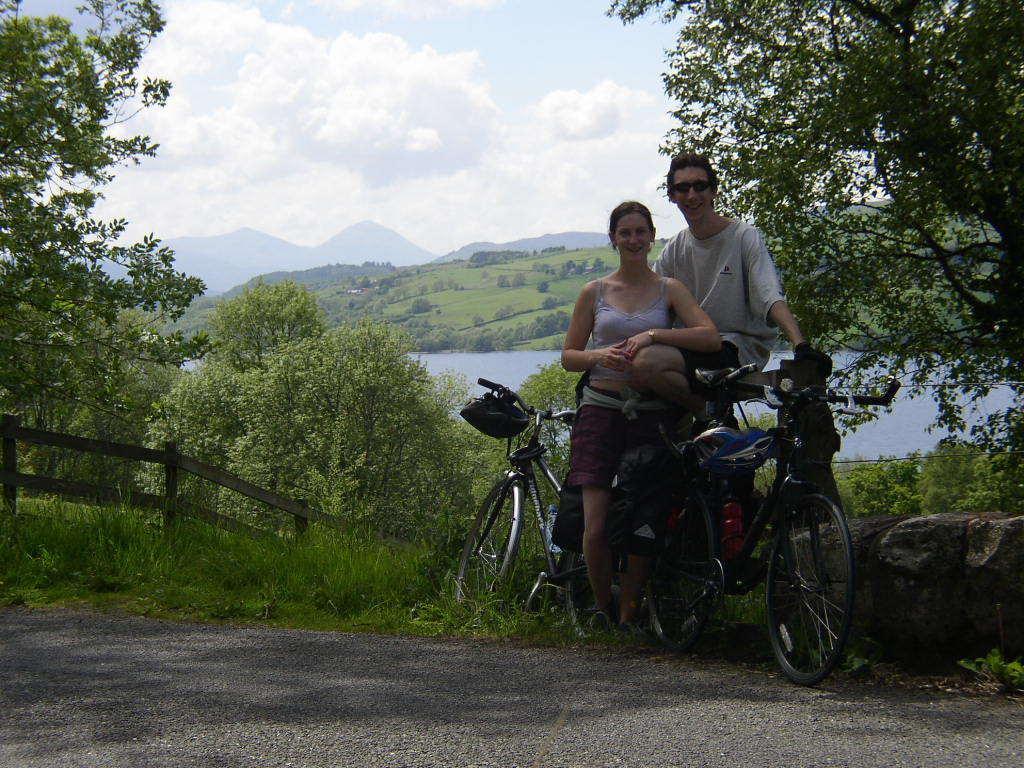Describe this image in one or two sentences. Sky is cloudy. Far there are number of trees. This 2 persons are standing. In between of this 2 persons there are 2 bicycles. Helmet is on bicycle. This is a freshwater river. Far there are mountains. 